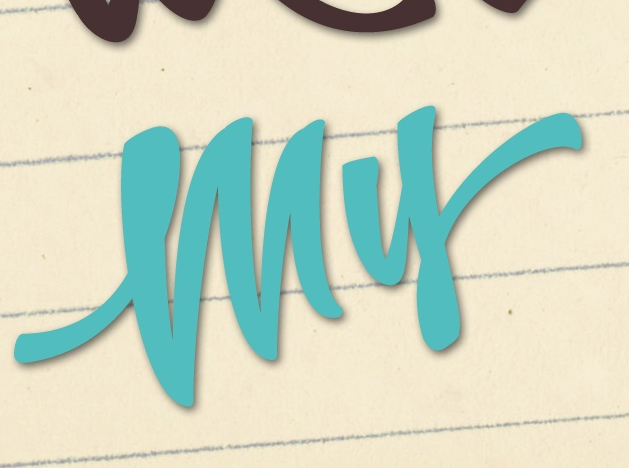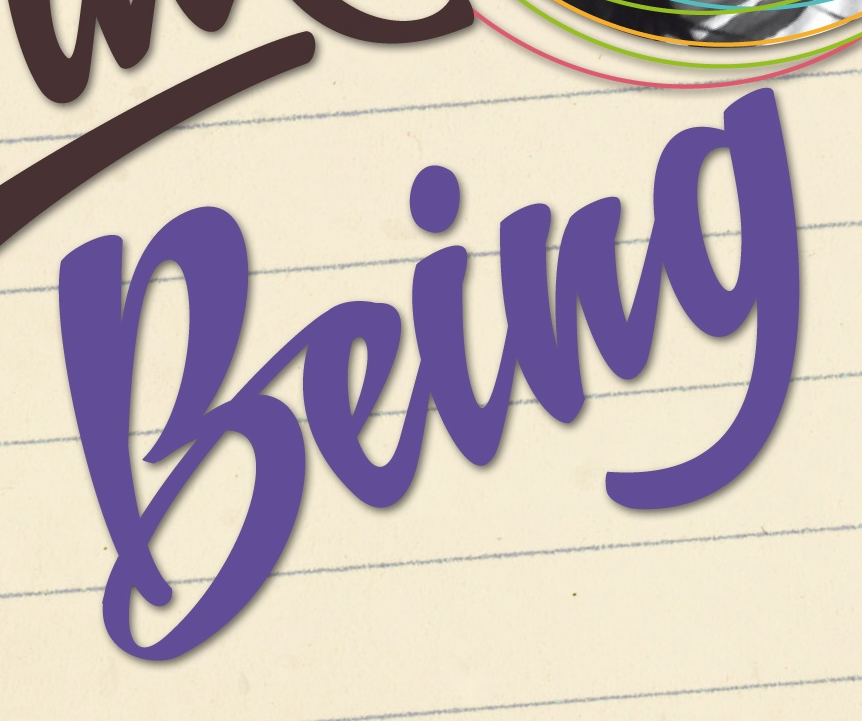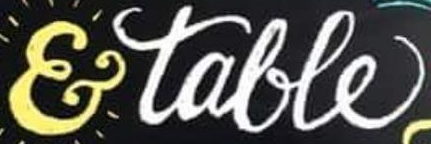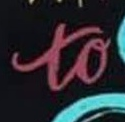What text appears in these images from left to right, separated by a semicolon? my; being; &talle; to 